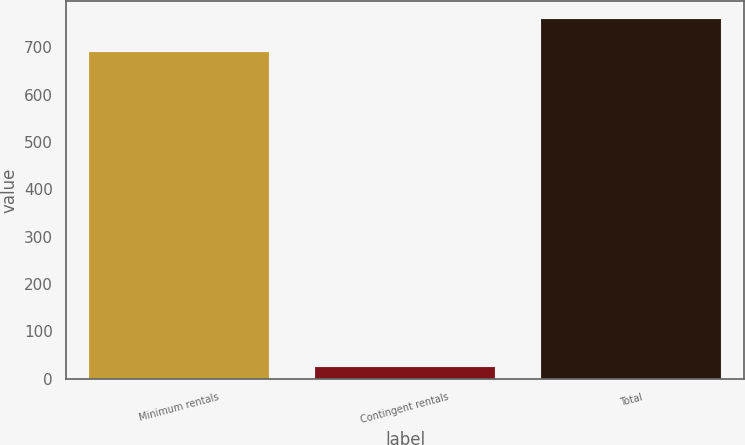Convert chart to OTSL. <chart><loc_0><loc_0><loc_500><loc_500><bar_chart><fcel>Minimum rentals<fcel>Contingent rentals<fcel>Total<nl><fcel>690<fcel>24.7<fcel>759<nl></chart> 